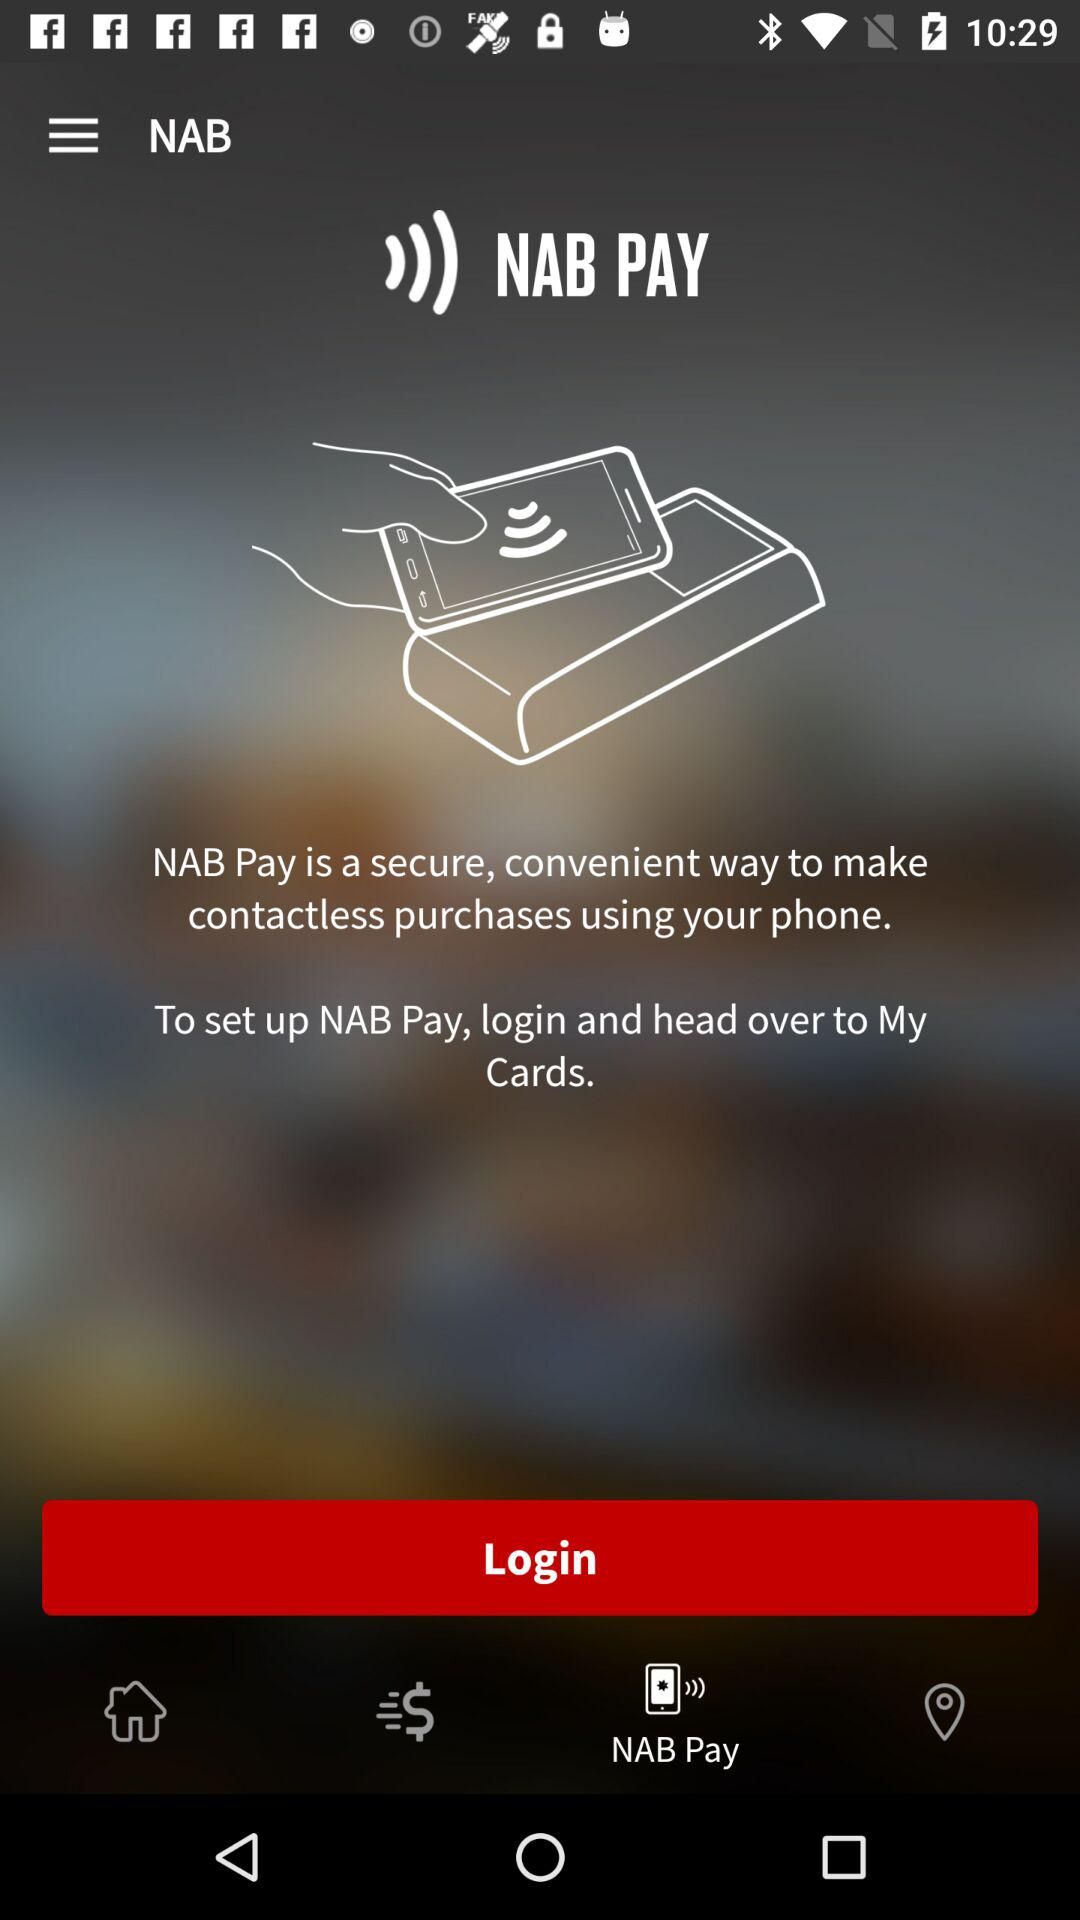What's the application name? The application name is "NAB PAY". 